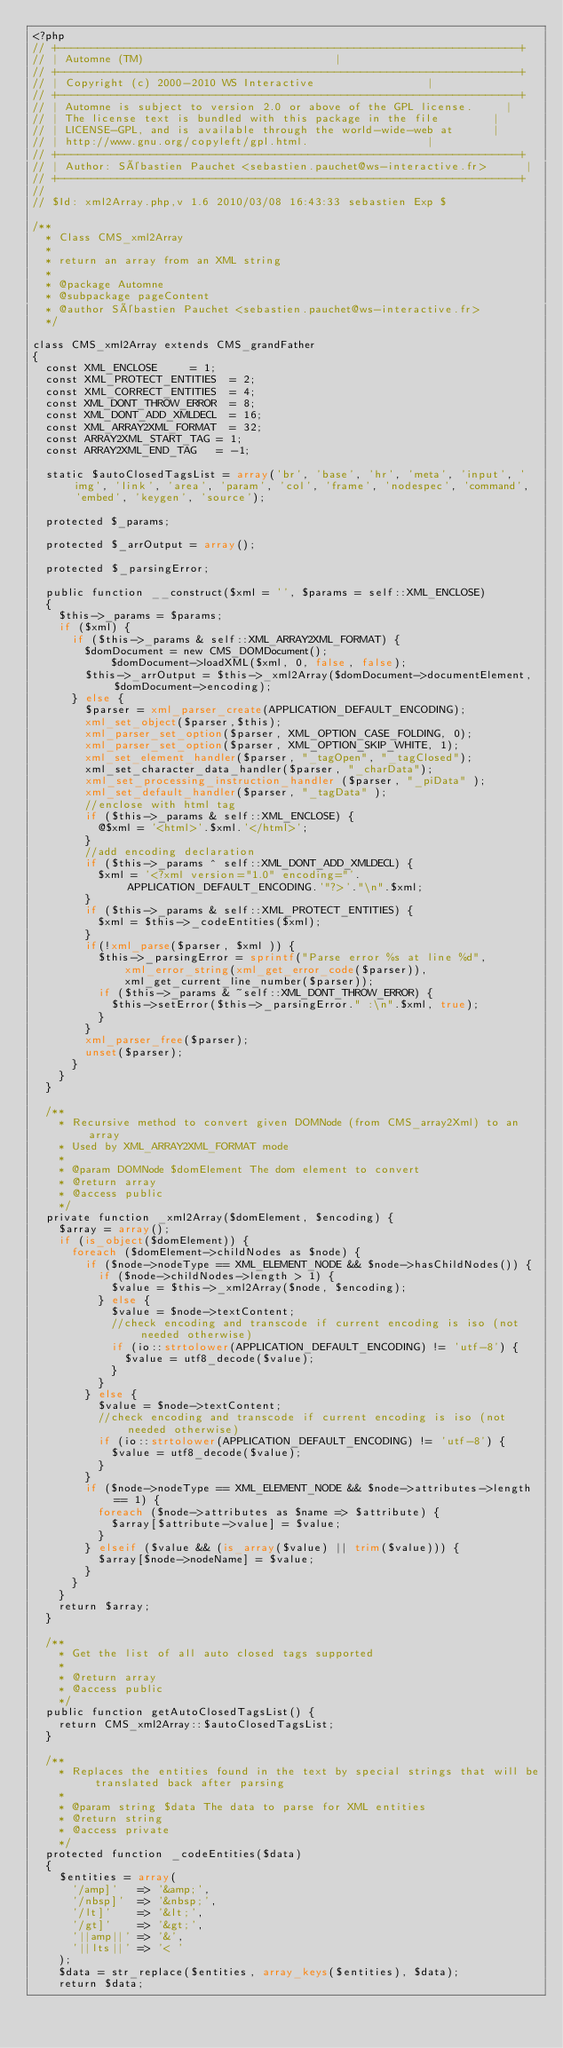Convert code to text. <code><loc_0><loc_0><loc_500><loc_500><_PHP_><?php
// +----------------------------------------------------------------------+
// | Automne (TM)														  |
// +----------------------------------------------------------------------+
// | Copyright (c) 2000-2010 WS Interactive								  |
// +----------------------------------------------------------------------+
// | Automne is subject to version 2.0 or above of the GPL license.		  |
// | The license text is bundled with this package in the file			  |
// | LICENSE-GPL, and is available through the world-wide-web at		  |
// | http://www.gnu.org/copyleft/gpl.html.								  |
// +----------------------------------------------------------------------+
// | Author: Sébastien Pauchet <sebastien.pauchet@ws-interactive.fr>      |
// +----------------------------------------------------------------------+
//
// $Id: xml2Array.php,v 1.6 2010/03/08 16:43:33 sebastien Exp $

/**
  * Class CMS_xml2Array
  *
  * return an array from an XML string
  *
  * @package Automne
  * @subpackage pageContent
  * @author Sébastien Pauchet <sebastien.pauchet@ws-interactive.fr>
  */

class CMS_xml2Array extends CMS_grandFather
{
	const XML_ENCLOSE			= 1;
	const XML_PROTECT_ENTITIES	= 2;
	const XML_CORRECT_ENTITIES	= 4;
	const XML_DONT_THROW_ERROR	= 8;
	const XML_DONT_ADD_XMLDECL	= 16;
	const XML_ARRAY2XML_FORMAT	= 32;
	const ARRAY2XML_START_TAG	= 1;
	const ARRAY2XML_END_TAG		= -1;
	
	static $autoClosedTagsList = array('br', 'base', 'hr', 'meta', 'input', 'img', 'link', 'area', 'param', 'col', 'frame', 'nodespec', 'command', 'embed', 'keygen', 'source');
	
	protected $_params;
	
	protected $_arrOutput = array();
	
	protected $_parsingError;
	
	public function __construct($xml = '', $params = self::XML_ENCLOSE)
	{
		$this->_params = $params;
		if ($xml) {
			if ($this->_params & self::XML_ARRAY2XML_FORMAT) {
				$domDocument = new CMS_DOMDocument();
		        $domDocument->loadXML($xml, 0, false, false);
				$this->_arrOutput = $this->_xml2Array($domDocument->documentElement, $domDocument->encoding);
			} else {
				$parser = xml_parser_create(APPLICATION_DEFAULT_ENCODING);
				xml_set_object($parser,$this);
				xml_parser_set_option($parser, XML_OPTION_CASE_FOLDING, 0);
				xml_parser_set_option($parser, XML_OPTION_SKIP_WHITE, 1);
				xml_set_element_handler($parser, "_tagOpen", "_tagClosed");
				xml_set_character_data_handler($parser, "_charData");
				xml_set_processing_instruction_handler ($parser, "_piData" );
				xml_set_default_handler($parser, "_tagData" );
				//enclose with html tag
				if ($this->_params & self::XML_ENCLOSE) {
					@$xml = '<html>'.$xml.'</html>';
				}
				//add encoding declaration
				if ($this->_params ^ self::XML_DONT_ADD_XMLDECL) {
					$xml = '<?xml version="1.0" encoding="'.APPLICATION_DEFAULT_ENCODING.'"?>'."\n".$xml;
				}
				if ($this->_params & self::XML_PROTECT_ENTITIES) {
					$xml = $this->_codeEntities($xml);
				}
				if(!xml_parse($parser, $xml )) {
					$this->_parsingError = sprintf("Parse error %s at line %d",
							xml_error_string(xml_get_error_code($parser)),
							xml_get_current_line_number($parser));
					if ($this->_params & ~self::XML_DONT_THROW_ERROR) {
						$this->setError($this->_parsingError." :\n".$xml, true);
					}
				}
				xml_parser_free($parser);
				unset($parser);
			}
		}
	}
	
	/**
	  * Recursive method to convert given DOMNode (from CMS_array2Xml) to an array
	  * Used by XML_ARRAY2XML_FORMAT mode
	  *
	  * @param DOMNode $domElement The dom element to convert
	  * @return array
	  * @access public
	  */
	private function _xml2Array($domElement, $encoding) {
		$array = array();
		if (is_object($domElement)) {
			foreach ($domElement->childNodes as $node) {
				if ($node->nodeType == XML_ELEMENT_NODE && $node->hasChildNodes()) {
					if ($node->childNodes->length > 1) {
						$value = $this->_xml2Array($node, $encoding);
					} else {
						$value = $node->textContent;
						//check encoding and transcode if current encoding is iso (not needed otherwise)
						if (io::strtolower(APPLICATION_DEFAULT_ENCODING) != 'utf-8') {
							$value = utf8_decode($value);
						}
					}
				} else {
					$value = $node->textContent;
					//check encoding and transcode if current encoding is iso (not needed otherwise)
					if (io::strtolower(APPLICATION_DEFAULT_ENCODING) != 'utf-8') {
						$value = utf8_decode($value);
					}
				}
				if ($node->nodeType == XML_ELEMENT_NODE && $node->attributes->length == 1) {
					foreach ($node->attributes as $name => $attribute) {
						$array[$attribute->value] = $value;
					}
				} elseif ($value && (is_array($value) || trim($value))) {
					$array[$node->nodeName] = $value;
				}
			}
		}
		return $array;
	}
	
	/**
	  * Get the list of all auto closed tags supported
	  *
	  * @return array
	  * @access public
	  */
	public function getAutoClosedTagsList() {
		return CMS_xml2Array::$autoClosedTagsList;
	}
	
	/**
	  * Replaces the entities found in the text by special strings that will be translated back after parsing
	  *
	  * @param string $data The data to parse for XML entities
	  * @return string
	  * @access private
	  */
	protected function _codeEntities($data)
	{
		$entities = array(
			'/amp]'		=> '&amp;',
			'/nbsp]'	=> '&nbsp;',
			'/lt]'		=> '&lt;',
			'/gt]'		=> '&gt;',
			'||amp||'	=> '&',
			'||lts||'	=> '< '
		);
		$data = str_replace($entities, array_keys($entities), $data);
		return $data;</code> 